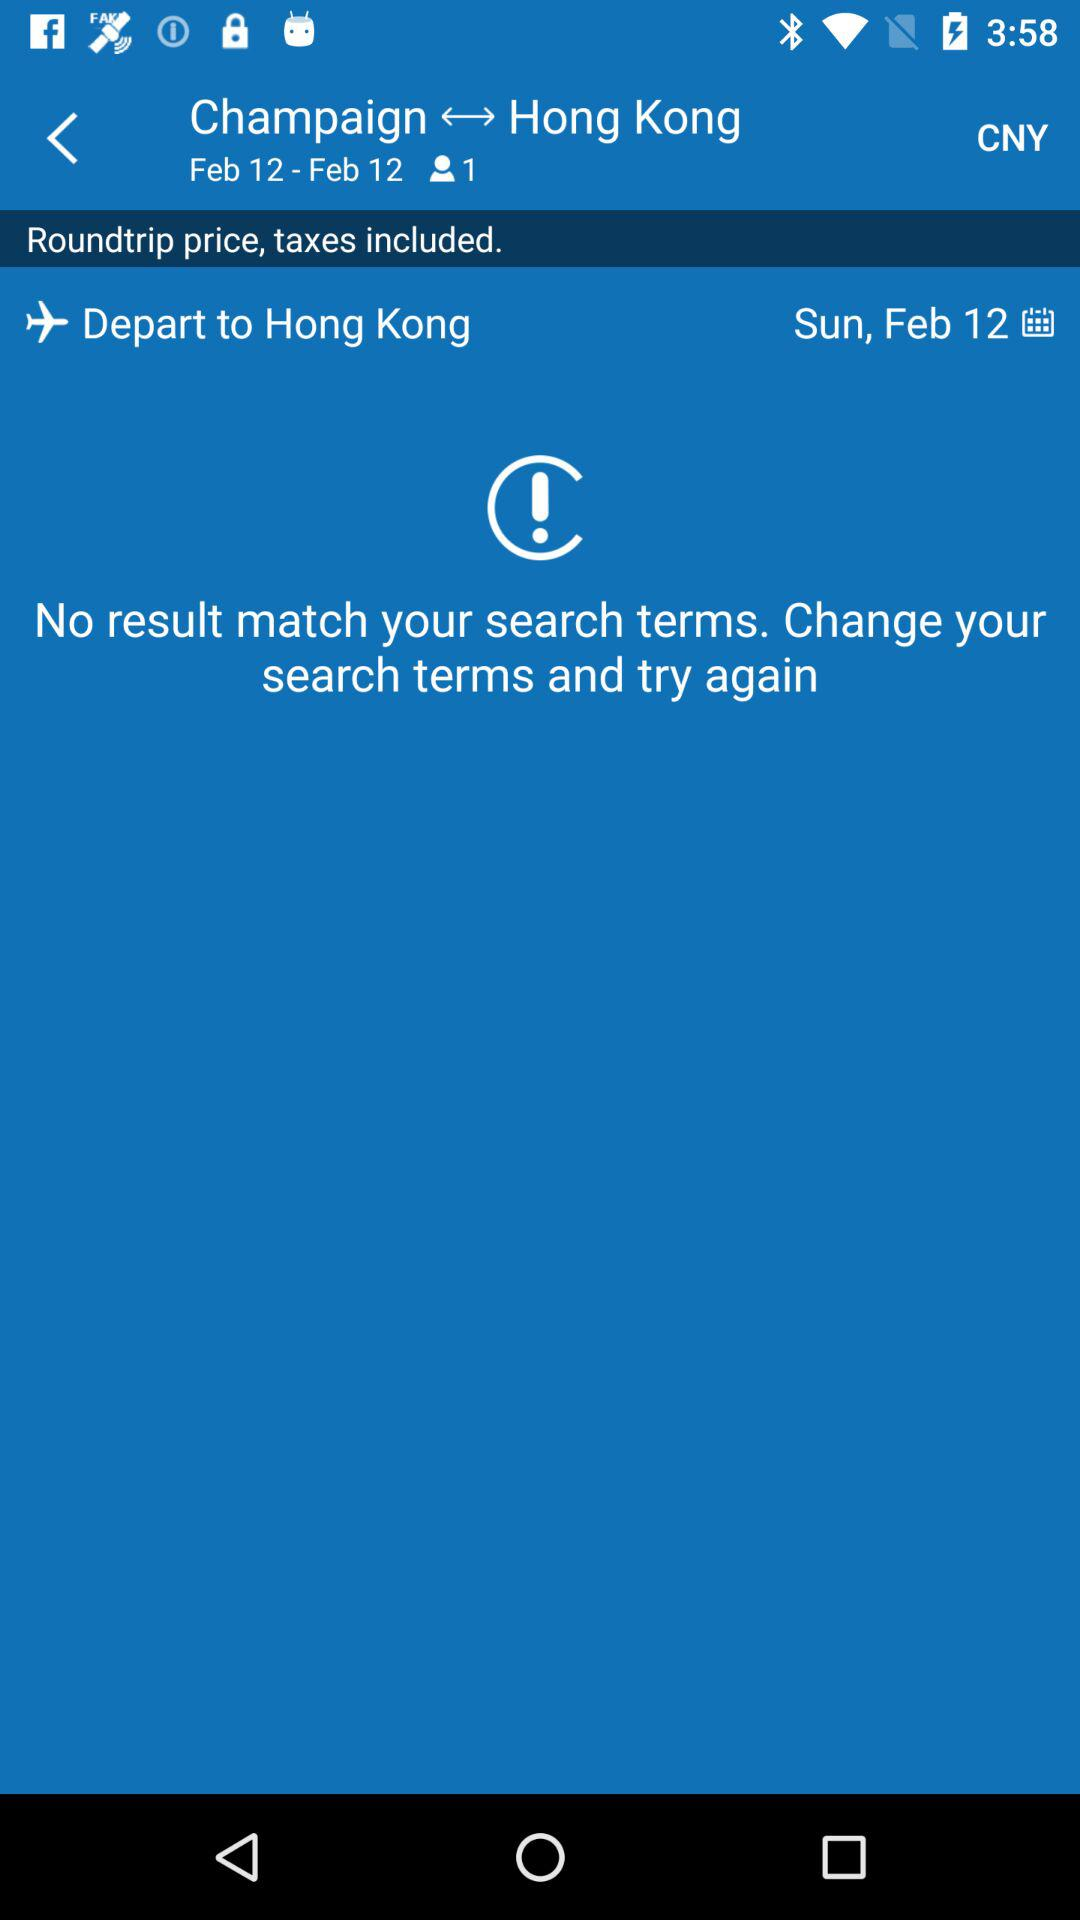How many people are flying?
Answer the question using a single word or phrase. 1 